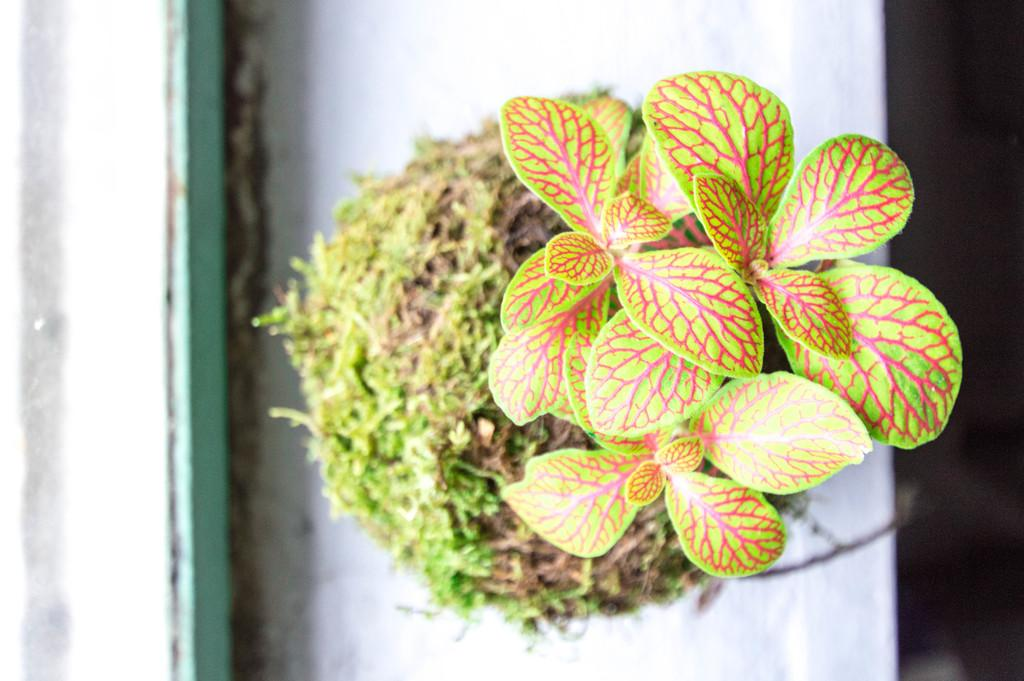What is the main subject of the image? The main subject of the image is a tree. What colors can be seen on the tree? The tree has green, brown, and pink colors. What is the surface beneath the tree? The tree is on a white surface. What color is the background of the image? The background of the image is black. Can you see any quilts hanging from the tree in the image? There are no quilts present in the image; it only features a tree with green, brown, and pink colors on a white surface, with a black background. 